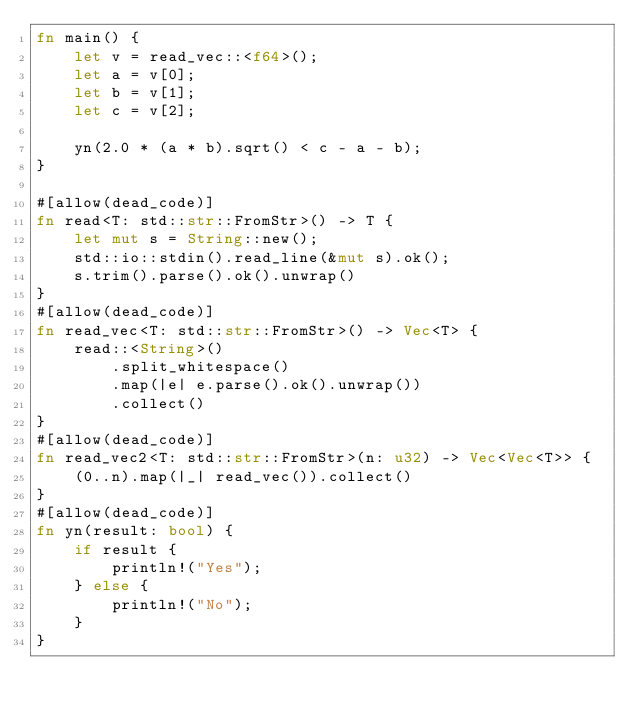<code> <loc_0><loc_0><loc_500><loc_500><_Rust_>fn main() {
    let v = read_vec::<f64>();
    let a = v[0];
    let b = v[1];
    let c = v[2];

    yn(2.0 * (a * b).sqrt() < c - a - b);
}

#[allow(dead_code)]
fn read<T: std::str::FromStr>() -> T {
    let mut s = String::new();
    std::io::stdin().read_line(&mut s).ok();
    s.trim().parse().ok().unwrap()
}
#[allow(dead_code)]
fn read_vec<T: std::str::FromStr>() -> Vec<T> {
    read::<String>()
        .split_whitespace()
        .map(|e| e.parse().ok().unwrap())
        .collect()
}
#[allow(dead_code)]
fn read_vec2<T: std::str::FromStr>(n: u32) -> Vec<Vec<T>> {
    (0..n).map(|_| read_vec()).collect()
}
#[allow(dead_code)]
fn yn(result: bool) {
    if result {
        println!("Yes");
    } else {
        println!("No");
    }
}
</code> 